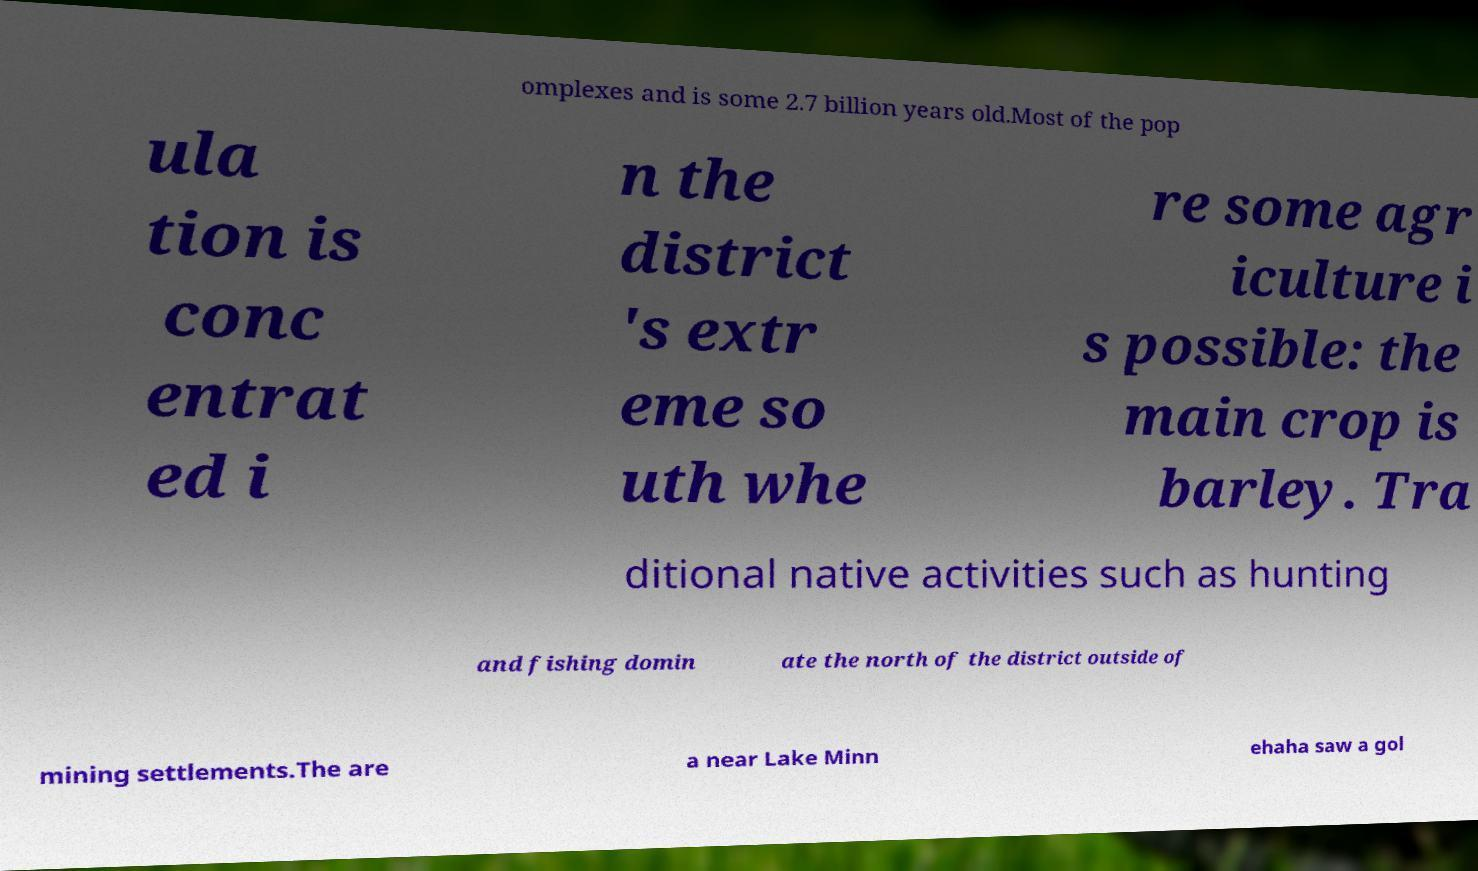Can you accurately transcribe the text from the provided image for me? omplexes and is some 2.7 billion years old.Most of the pop ula tion is conc entrat ed i n the district 's extr eme so uth whe re some agr iculture i s possible: the main crop is barley. Tra ditional native activities such as hunting and fishing domin ate the north of the district outside of mining settlements.The are a near Lake Minn ehaha saw a gol 